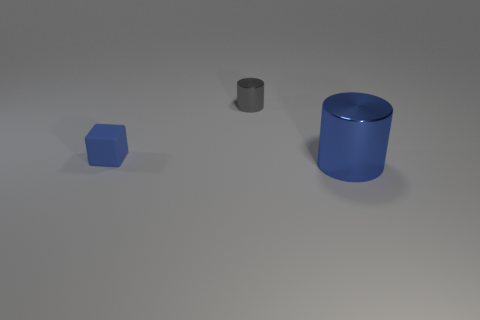There is a object that is the same color as the big cylinder; what is its shape?
Your answer should be very brief. Cube. There is a thing that is behind the block; does it have the same size as the thing in front of the tiny cube?
Your answer should be very brief. No. Is there a small brown thing that has the same shape as the tiny blue object?
Your response must be concise. No. Are there the same number of blue rubber things in front of the large blue cylinder and rubber blocks?
Make the answer very short. No. Does the blue metal cylinder have the same size as the blue cube that is in front of the gray cylinder?
Offer a very short reply. No. What number of yellow balls are the same material as the gray object?
Your answer should be very brief. 0. Is the blue block the same size as the gray thing?
Offer a terse response. Yes. Is there any other thing that is the same color as the large metallic cylinder?
Offer a terse response. Yes. What shape is the thing that is both in front of the small gray cylinder and to the left of the blue shiny thing?
Offer a very short reply. Cube. There is a blue object to the right of the gray cylinder; what is its size?
Ensure brevity in your answer.  Large. 